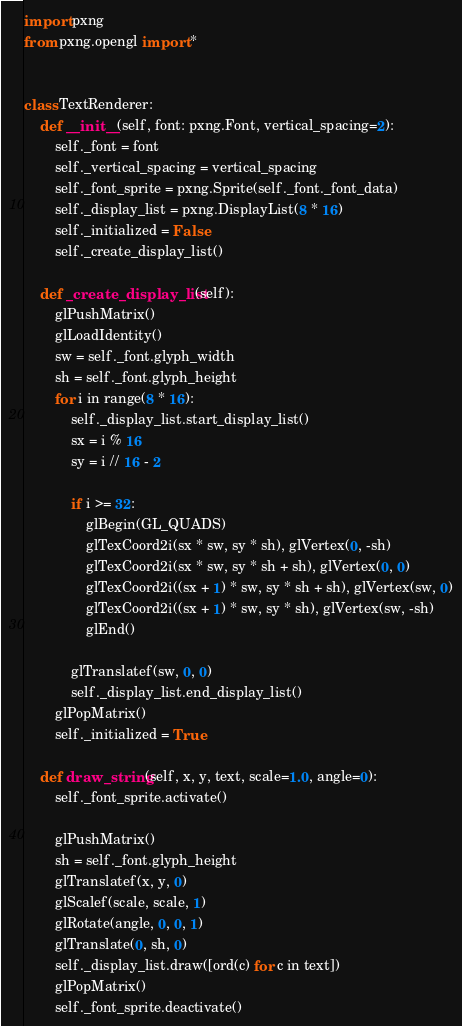Convert code to text. <code><loc_0><loc_0><loc_500><loc_500><_Python_>import pxng
from pxng.opengl import *


class TextRenderer:
    def __init__(self, font: pxng.Font, vertical_spacing=2):
        self._font = font
        self._vertical_spacing = vertical_spacing
        self._font_sprite = pxng.Sprite(self._font._font_data)
        self._display_list = pxng.DisplayList(8 * 16)
        self._initialized = False
        self._create_display_list()

    def _create_display_list(self):
        glPushMatrix()
        glLoadIdentity()
        sw = self._font.glyph_width
        sh = self._font.glyph_height
        for i in range(8 * 16):
            self._display_list.start_display_list()
            sx = i % 16
            sy = i // 16 - 2

            if i >= 32:
                glBegin(GL_QUADS)
                glTexCoord2i(sx * sw, sy * sh), glVertex(0, -sh)
                glTexCoord2i(sx * sw, sy * sh + sh), glVertex(0, 0)
                glTexCoord2i((sx + 1) * sw, sy * sh + sh), glVertex(sw, 0)
                glTexCoord2i((sx + 1) * sw, sy * sh), glVertex(sw, -sh)
                glEnd()

            glTranslatef(sw, 0, 0)
            self._display_list.end_display_list()
        glPopMatrix()
        self._initialized = True

    def draw_string(self, x, y, text, scale=1.0, angle=0):
        self._font_sprite.activate()

        glPushMatrix()
        sh = self._font.glyph_height
        glTranslatef(x, y, 0)
        glScalef(scale, scale, 1)
        glRotate(angle, 0, 0, 1)
        glTranslate(0, sh, 0)
        self._display_list.draw([ord(c) for c in text])
        glPopMatrix()
        self._font_sprite.deactivate()
</code> 